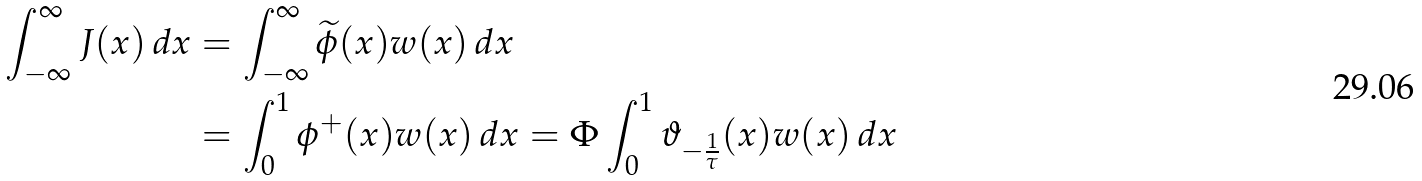<formula> <loc_0><loc_0><loc_500><loc_500>\int _ { - \infty } ^ { \infty } J ( x ) \, d x & = \int _ { - \infty } ^ { \infty } \widetilde { \phi } ( x ) w ( x ) \, d x \\ & = \int _ { 0 } ^ { 1 } \phi ^ { + } ( x ) w ( x ) \, d x = \Phi \int _ { 0 } ^ { 1 } \vartheta _ { - \frac { 1 } { \tau } } ( x ) w ( x ) \, d x</formula> 